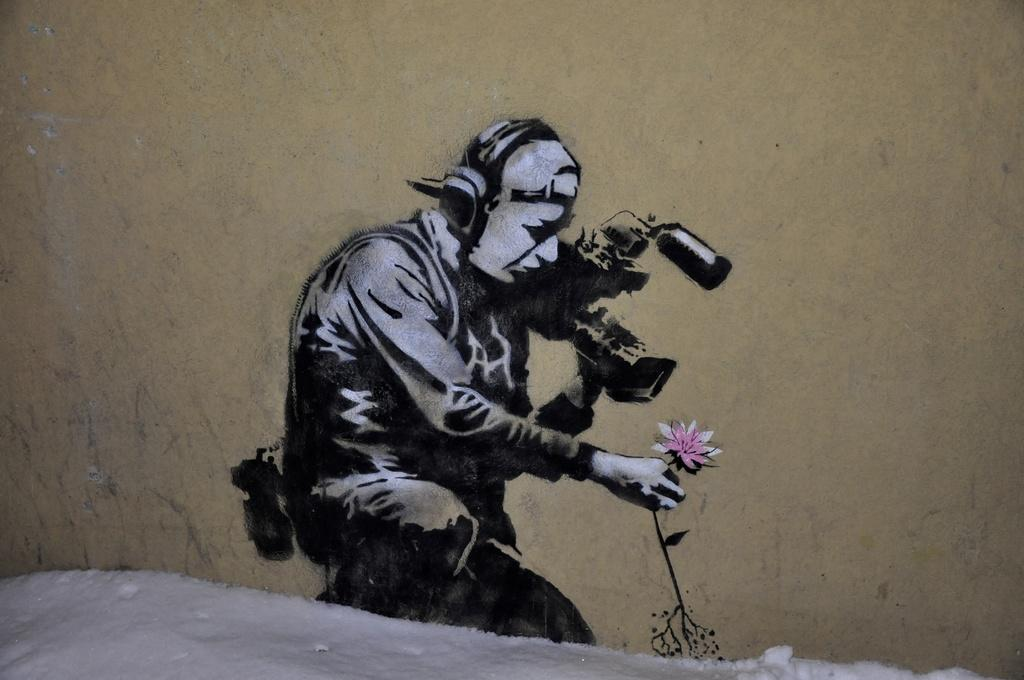What is present in the image along with the person? There is an object in the image. What can be seen on the wall in the image? There is a flowers painting on a wall in the image. Can you describe the lighting conditions in the image? The image was likely taken during the day, suggesting there is ample natural light. What type of location might the image have been taken in? The image was likely taken on an ice road. What type of produce is being sold by the person in the image? There is no produce present in the image, as the person is not engaged in any activity related to selling or buying produce. 